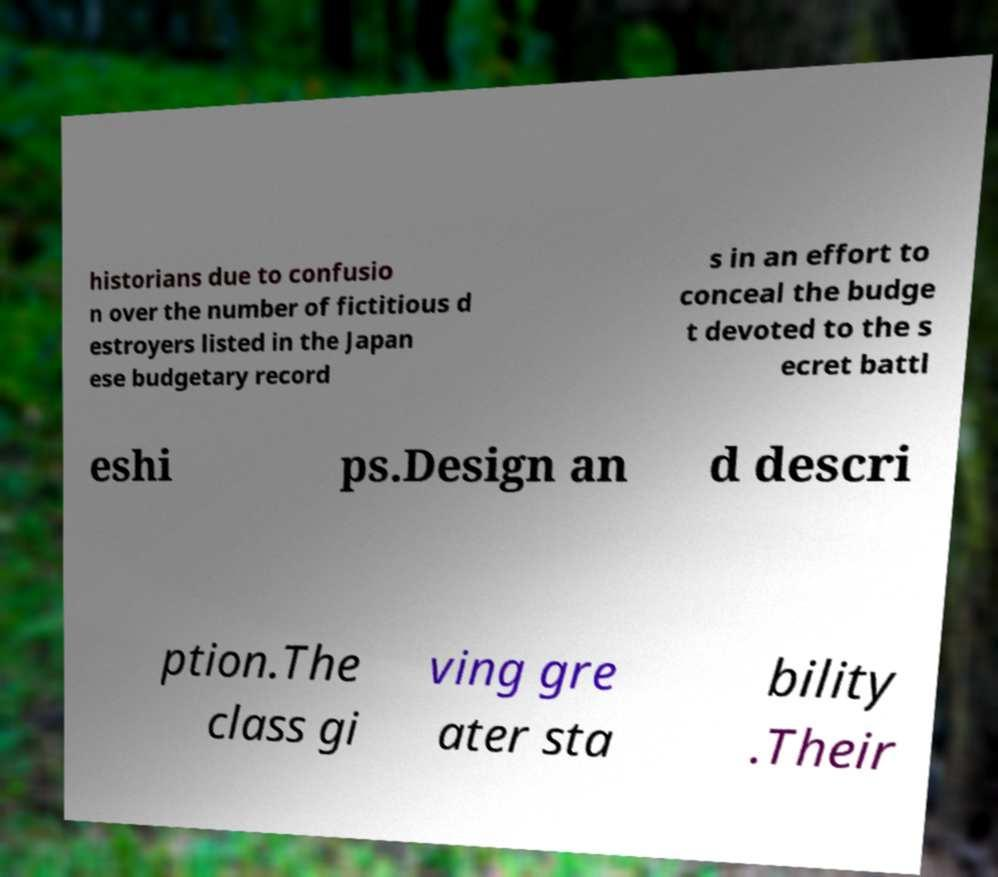I need the written content from this picture converted into text. Can you do that? historians due to confusio n over the number of fictitious d estroyers listed in the Japan ese budgetary record s in an effort to conceal the budge t devoted to the s ecret battl eshi ps.Design an d descri ption.The class gi ving gre ater sta bility .Their 